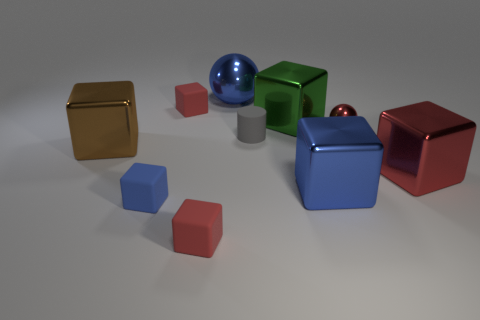Subtract all large blocks. How many blocks are left? 3 Subtract all spheres. How many objects are left? 8 Subtract 4 cubes. How many cubes are left? 3 Subtract all brown cubes. How many cubes are left? 6 Add 8 small gray cylinders. How many small gray cylinders are left? 9 Add 3 green things. How many green things exist? 4 Subtract 0 gray balls. How many objects are left? 10 Subtract all brown spheres. Subtract all purple cylinders. How many spheres are left? 2 Subtract all gray cylinders. How many red cubes are left? 3 Subtract all small cylinders. Subtract all big red blocks. How many objects are left? 8 